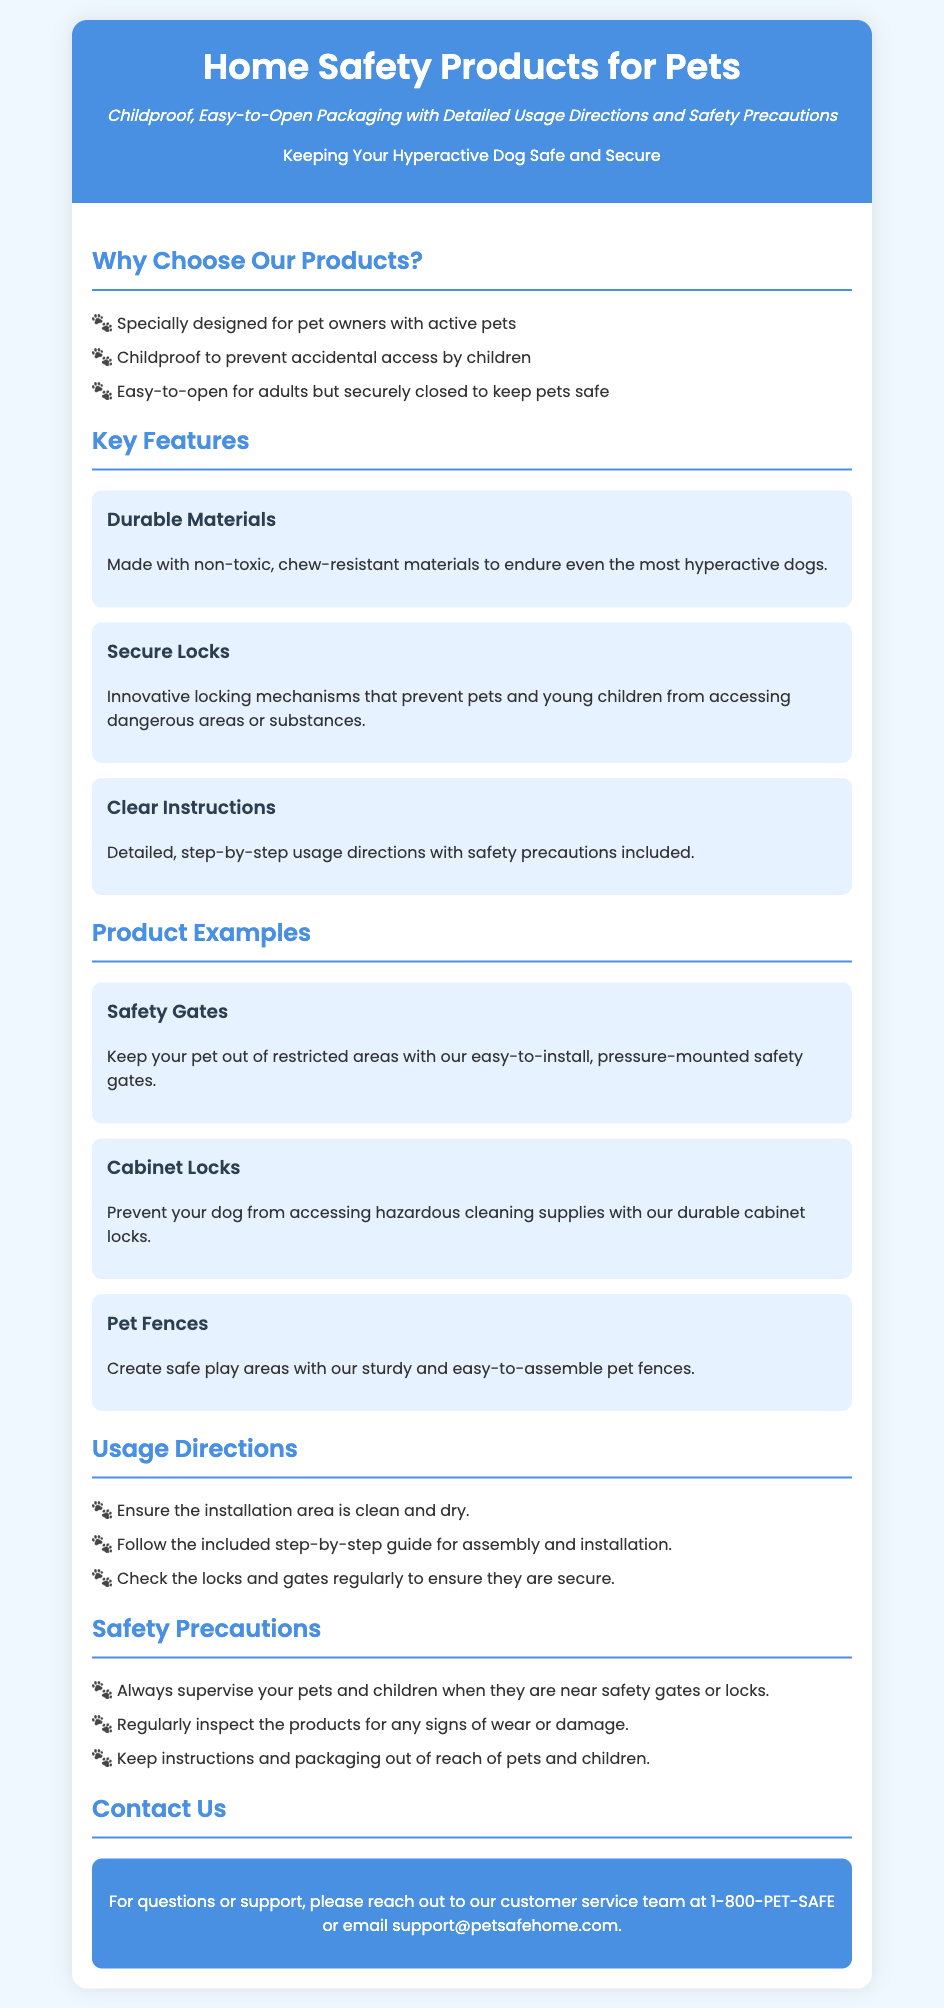what is the title of the document? The title is specified in the <title> tag of the HTML document.
Answer: Home Safety Products for Pets what is the purpose of the packaging? The purpose is described in the subtitle of the document, indicating a focus on childproofing and easy access for adults.
Answer: Childproof, Easy-to-Open Packaging what are two key features of the products? The features are listed in the "Key Features" section of the document.
Answer: Durable Materials, Secure Locks how many product examples are provided? The number of product examples can be counted in the "Product Examples" section.
Answer: Three what should you do before installation? The first step in the "Usage Directions" section addresses this.
Answer: Ensure the installation area is clean and dry what is a safety precaution mentioned in the document? The "Safety Precautions" section lists various safety measures to take.
Answer: Always supervise your pets and children what is the contact number for customer support? The contact information is provided in the "Contact Us" section of the document.
Answer: 1-800-PET-SAFE who is the target audience for these products? The target audience is implied through descriptions focused on safety for active pets and children.
Answer: Pet owners with active pets 